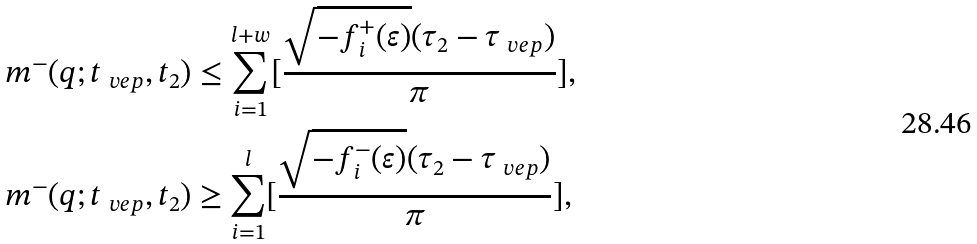<formula> <loc_0><loc_0><loc_500><loc_500>m ^ { - } ( q ; t _ { \ v e p } , t _ { 2 } ) & \leq \sum _ { i = 1 } ^ { l + w } [ \frac { \sqrt { - f ^ { + } _ { i } ( \varepsilon ) } ( \tau _ { 2 } - \tau _ { \ v e p } ) } { \pi } ] , \\ m ^ { - } ( q ; t _ { \ v e p } , t _ { 2 } ) & \geq \sum _ { i = 1 } ^ { l } [ \frac { \sqrt { - f ^ { - } _ { i } ( \varepsilon ) } ( \tau _ { 2 } - \tau _ { \ v e p } ) } { \pi } ] ,</formula> 